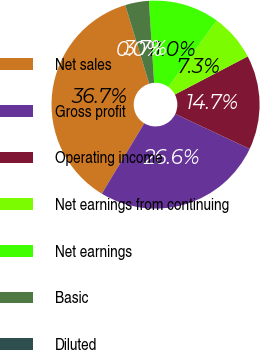Convert chart. <chart><loc_0><loc_0><loc_500><loc_500><pie_chart><fcel>Net sales<fcel>Gross profit<fcel>Operating income<fcel>Net earnings from continuing<fcel>Net earnings<fcel>Basic<fcel>Diluted<nl><fcel>36.66%<fcel>26.64%<fcel>14.67%<fcel>7.34%<fcel>11.01%<fcel>3.68%<fcel>0.01%<nl></chart> 